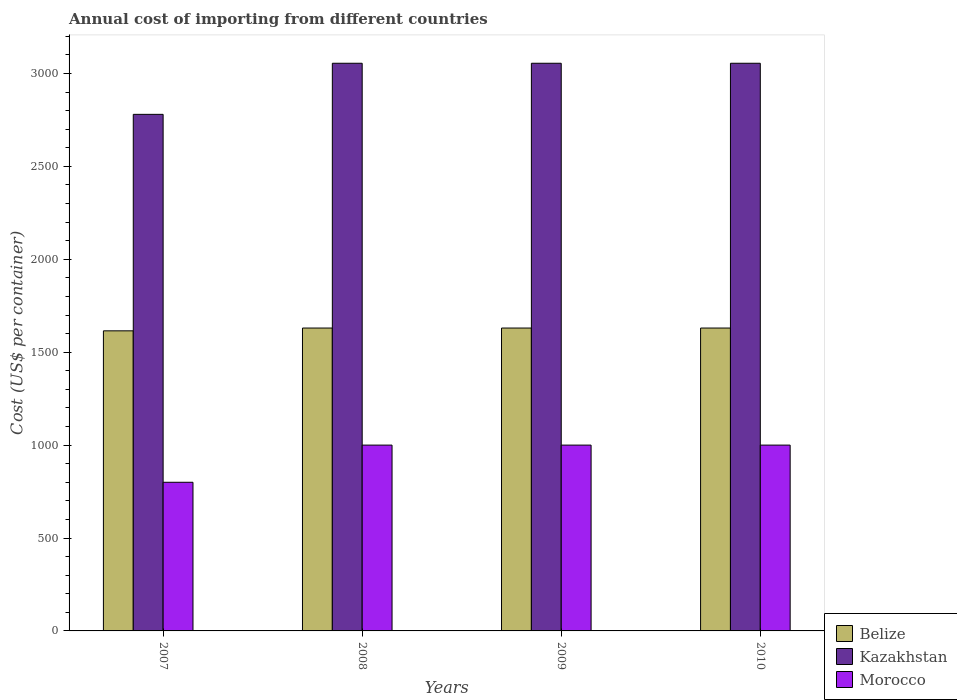How many different coloured bars are there?
Ensure brevity in your answer.  3. Are the number of bars per tick equal to the number of legend labels?
Your answer should be very brief. Yes. Are the number of bars on each tick of the X-axis equal?
Make the answer very short. Yes. How many bars are there on the 3rd tick from the left?
Provide a succinct answer. 3. How many bars are there on the 1st tick from the right?
Your answer should be very brief. 3. In how many cases, is the number of bars for a given year not equal to the number of legend labels?
Your answer should be very brief. 0. What is the total annual cost of importing in Belize in 2008?
Your answer should be very brief. 1630. Across all years, what is the maximum total annual cost of importing in Morocco?
Your answer should be compact. 1000. Across all years, what is the minimum total annual cost of importing in Belize?
Your answer should be compact. 1615. What is the total total annual cost of importing in Kazakhstan in the graph?
Give a very brief answer. 1.19e+04. What is the difference between the total annual cost of importing in Morocco in 2008 and that in 2010?
Provide a succinct answer. 0. What is the difference between the total annual cost of importing in Belize in 2008 and the total annual cost of importing in Kazakhstan in 2009?
Give a very brief answer. -1425. What is the average total annual cost of importing in Belize per year?
Your answer should be compact. 1626.25. In the year 2010, what is the difference between the total annual cost of importing in Belize and total annual cost of importing in Kazakhstan?
Your response must be concise. -1425. In how many years, is the total annual cost of importing in Morocco greater than 1300 US$?
Give a very brief answer. 0. What is the difference between the highest and the second highest total annual cost of importing in Belize?
Offer a very short reply. 0. What is the difference between the highest and the lowest total annual cost of importing in Kazakhstan?
Provide a succinct answer. 275. In how many years, is the total annual cost of importing in Morocco greater than the average total annual cost of importing in Morocco taken over all years?
Give a very brief answer. 3. What does the 1st bar from the left in 2008 represents?
Make the answer very short. Belize. What does the 2nd bar from the right in 2009 represents?
Provide a short and direct response. Kazakhstan. Is it the case that in every year, the sum of the total annual cost of importing in Morocco and total annual cost of importing in Belize is greater than the total annual cost of importing in Kazakhstan?
Give a very brief answer. No. How many bars are there?
Give a very brief answer. 12. Are all the bars in the graph horizontal?
Keep it short and to the point. No. How many years are there in the graph?
Give a very brief answer. 4. Are the values on the major ticks of Y-axis written in scientific E-notation?
Your response must be concise. No. Does the graph contain grids?
Provide a short and direct response. No. Where does the legend appear in the graph?
Make the answer very short. Bottom right. How many legend labels are there?
Provide a succinct answer. 3. How are the legend labels stacked?
Ensure brevity in your answer.  Vertical. What is the title of the graph?
Offer a very short reply. Annual cost of importing from different countries. What is the label or title of the X-axis?
Provide a succinct answer. Years. What is the label or title of the Y-axis?
Keep it short and to the point. Cost (US$ per container). What is the Cost (US$ per container) of Belize in 2007?
Keep it short and to the point. 1615. What is the Cost (US$ per container) of Kazakhstan in 2007?
Offer a terse response. 2780. What is the Cost (US$ per container) in Morocco in 2007?
Your answer should be compact. 800. What is the Cost (US$ per container) of Belize in 2008?
Provide a succinct answer. 1630. What is the Cost (US$ per container) of Kazakhstan in 2008?
Give a very brief answer. 3055. What is the Cost (US$ per container) in Belize in 2009?
Make the answer very short. 1630. What is the Cost (US$ per container) in Kazakhstan in 2009?
Make the answer very short. 3055. What is the Cost (US$ per container) of Morocco in 2009?
Your answer should be very brief. 1000. What is the Cost (US$ per container) in Belize in 2010?
Keep it short and to the point. 1630. What is the Cost (US$ per container) of Kazakhstan in 2010?
Your answer should be compact. 3055. Across all years, what is the maximum Cost (US$ per container) in Belize?
Ensure brevity in your answer.  1630. Across all years, what is the maximum Cost (US$ per container) in Kazakhstan?
Keep it short and to the point. 3055. Across all years, what is the minimum Cost (US$ per container) of Belize?
Ensure brevity in your answer.  1615. Across all years, what is the minimum Cost (US$ per container) of Kazakhstan?
Your answer should be very brief. 2780. Across all years, what is the minimum Cost (US$ per container) of Morocco?
Give a very brief answer. 800. What is the total Cost (US$ per container) of Belize in the graph?
Your answer should be very brief. 6505. What is the total Cost (US$ per container) of Kazakhstan in the graph?
Offer a very short reply. 1.19e+04. What is the total Cost (US$ per container) of Morocco in the graph?
Ensure brevity in your answer.  3800. What is the difference between the Cost (US$ per container) in Kazakhstan in 2007 and that in 2008?
Keep it short and to the point. -275. What is the difference between the Cost (US$ per container) in Morocco in 2007 and that in 2008?
Offer a terse response. -200. What is the difference between the Cost (US$ per container) in Belize in 2007 and that in 2009?
Keep it short and to the point. -15. What is the difference between the Cost (US$ per container) in Kazakhstan in 2007 and that in 2009?
Provide a short and direct response. -275. What is the difference between the Cost (US$ per container) of Morocco in 2007 and that in 2009?
Provide a succinct answer. -200. What is the difference between the Cost (US$ per container) of Belize in 2007 and that in 2010?
Ensure brevity in your answer.  -15. What is the difference between the Cost (US$ per container) of Kazakhstan in 2007 and that in 2010?
Keep it short and to the point. -275. What is the difference between the Cost (US$ per container) of Morocco in 2007 and that in 2010?
Keep it short and to the point. -200. What is the difference between the Cost (US$ per container) of Belize in 2008 and that in 2009?
Make the answer very short. 0. What is the difference between the Cost (US$ per container) of Kazakhstan in 2008 and that in 2009?
Your answer should be very brief. 0. What is the difference between the Cost (US$ per container) in Morocco in 2008 and that in 2009?
Provide a succinct answer. 0. What is the difference between the Cost (US$ per container) of Kazakhstan in 2008 and that in 2010?
Your answer should be very brief. 0. What is the difference between the Cost (US$ per container) in Morocco in 2008 and that in 2010?
Your response must be concise. 0. What is the difference between the Cost (US$ per container) in Kazakhstan in 2009 and that in 2010?
Offer a very short reply. 0. What is the difference between the Cost (US$ per container) in Belize in 2007 and the Cost (US$ per container) in Kazakhstan in 2008?
Make the answer very short. -1440. What is the difference between the Cost (US$ per container) in Belize in 2007 and the Cost (US$ per container) in Morocco in 2008?
Give a very brief answer. 615. What is the difference between the Cost (US$ per container) in Kazakhstan in 2007 and the Cost (US$ per container) in Morocco in 2008?
Your response must be concise. 1780. What is the difference between the Cost (US$ per container) in Belize in 2007 and the Cost (US$ per container) in Kazakhstan in 2009?
Give a very brief answer. -1440. What is the difference between the Cost (US$ per container) in Belize in 2007 and the Cost (US$ per container) in Morocco in 2009?
Offer a terse response. 615. What is the difference between the Cost (US$ per container) in Kazakhstan in 2007 and the Cost (US$ per container) in Morocco in 2009?
Provide a short and direct response. 1780. What is the difference between the Cost (US$ per container) of Belize in 2007 and the Cost (US$ per container) of Kazakhstan in 2010?
Keep it short and to the point. -1440. What is the difference between the Cost (US$ per container) in Belize in 2007 and the Cost (US$ per container) in Morocco in 2010?
Your answer should be very brief. 615. What is the difference between the Cost (US$ per container) of Kazakhstan in 2007 and the Cost (US$ per container) of Morocco in 2010?
Your response must be concise. 1780. What is the difference between the Cost (US$ per container) of Belize in 2008 and the Cost (US$ per container) of Kazakhstan in 2009?
Offer a terse response. -1425. What is the difference between the Cost (US$ per container) in Belize in 2008 and the Cost (US$ per container) in Morocco in 2009?
Give a very brief answer. 630. What is the difference between the Cost (US$ per container) of Kazakhstan in 2008 and the Cost (US$ per container) of Morocco in 2009?
Keep it short and to the point. 2055. What is the difference between the Cost (US$ per container) of Belize in 2008 and the Cost (US$ per container) of Kazakhstan in 2010?
Provide a succinct answer. -1425. What is the difference between the Cost (US$ per container) in Belize in 2008 and the Cost (US$ per container) in Morocco in 2010?
Provide a succinct answer. 630. What is the difference between the Cost (US$ per container) of Kazakhstan in 2008 and the Cost (US$ per container) of Morocco in 2010?
Offer a very short reply. 2055. What is the difference between the Cost (US$ per container) of Belize in 2009 and the Cost (US$ per container) of Kazakhstan in 2010?
Provide a succinct answer. -1425. What is the difference between the Cost (US$ per container) in Belize in 2009 and the Cost (US$ per container) in Morocco in 2010?
Provide a short and direct response. 630. What is the difference between the Cost (US$ per container) in Kazakhstan in 2009 and the Cost (US$ per container) in Morocco in 2010?
Keep it short and to the point. 2055. What is the average Cost (US$ per container) of Belize per year?
Your answer should be compact. 1626.25. What is the average Cost (US$ per container) of Kazakhstan per year?
Make the answer very short. 2986.25. What is the average Cost (US$ per container) in Morocco per year?
Ensure brevity in your answer.  950. In the year 2007, what is the difference between the Cost (US$ per container) of Belize and Cost (US$ per container) of Kazakhstan?
Keep it short and to the point. -1165. In the year 2007, what is the difference between the Cost (US$ per container) of Belize and Cost (US$ per container) of Morocco?
Provide a short and direct response. 815. In the year 2007, what is the difference between the Cost (US$ per container) of Kazakhstan and Cost (US$ per container) of Morocco?
Provide a short and direct response. 1980. In the year 2008, what is the difference between the Cost (US$ per container) of Belize and Cost (US$ per container) of Kazakhstan?
Your answer should be very brief. -1425. In the year 2008, what is the difference between the Cost (US$ per container) in Belize and Cost (US$ per container) in Morocco?
Make the answer very short. 630. In the year 2008, what is the difference between the Cost (US$ per container) of Kazakhstan and Cost (US$ per container) of Morocco?
Offer a very short reply. 2055. In the year 2009, what is the difference between the Cost (US$ per container) in Belize and Cost (US$ per container) in Kazakhstan?
Your response must be concise. -1425. In the year 2009, what is the difference between the Cost (US$ per container) of Belize and Cost (US$ per container) of Morocco?
Your answer should be very brief. 630. In the year 2009, what is the difference between the Cost (US$ per container) of Kazakhstan and Cost (US$ per container) of Morocco?
Give a very brief answer. 2055. In the year 2010, what is the difference between the Cost (US$ per container) in Belize and Cost (US$ per container) in Kazakhstan?
Give a very brief answer. -1425. In the year 2010, what is the difference between the Cost (US$ per container) in Belize and Cost (US$ per container) in Morocco?
Your response must be concise. 630. In the year 2010, what is the difference between the Cost (US$ per container) in Kazakhstan and Cost (US$ per container) in Morocco?
Make the answer very short. 2055. What is the ratio of the Cost (US$ per container) of Belize in 2007 to that in 2008?
Ensure brevity in your answer.  0.99. What is the ratio of the Cost (US$ per container) of Kazakhstan in 2007 to that in 2008?
Make the answer very short. 0.91. What is the ratio of the Cost (US$ per container) in Belize in 2007 to that in 2009?
Make the answer very short. 0.99. What is the ratio of the Cost (US$ per container) in Kazakhstan in 2007 to that in 2009?
Make the answer very short. 0.91. What is the ratio of the Cost (US$ per container) of Belize in 2007 to that in 2010?
Your answer should be very brief. 0.99. What is the ratio of the Cost (US$ per container) in Kazakhstan in 2007 to that in 2010?
Give a very brief answer. 0.91. What is the ratio of the Cost (US$ per container) in Morocco in 2008 to that in 2009?
Your answer should be very brief. 1. What is the ratio of the Cost (US$ per container) of Belize in 2008 to that in 2010?
Offer a very short reply. 1. What is the ratio of the Cost (US$ per container) of Kazakhstan in 2008 to that in 2010?
Your answer should be very brief. 1. What is the ratio of the Cost (US$ per container) of Belize in 2009 to that in 2010?
Ensure brevity in your answer.  1. What is the difference between the highest and the second highest Cost (US$ per container) in Kazakhstan?
Offer a terse response. 0. What is the difference between the highest and the second highest Cost (US$ per container) of Morocco?
Your answer should be compact. 0. What is the difference between the highest and the lowest Cost (US$ per container) of Belize?
Provide a succinct answer. 15. What is the difference between the highest and the lowest Cost (US$ per container) of Kazakhstan?
Make the answer very short. 275. What is the difference between the highest and the lowest Cost (US$ per container) in Morocco?
Give a very brief answer. 200. 